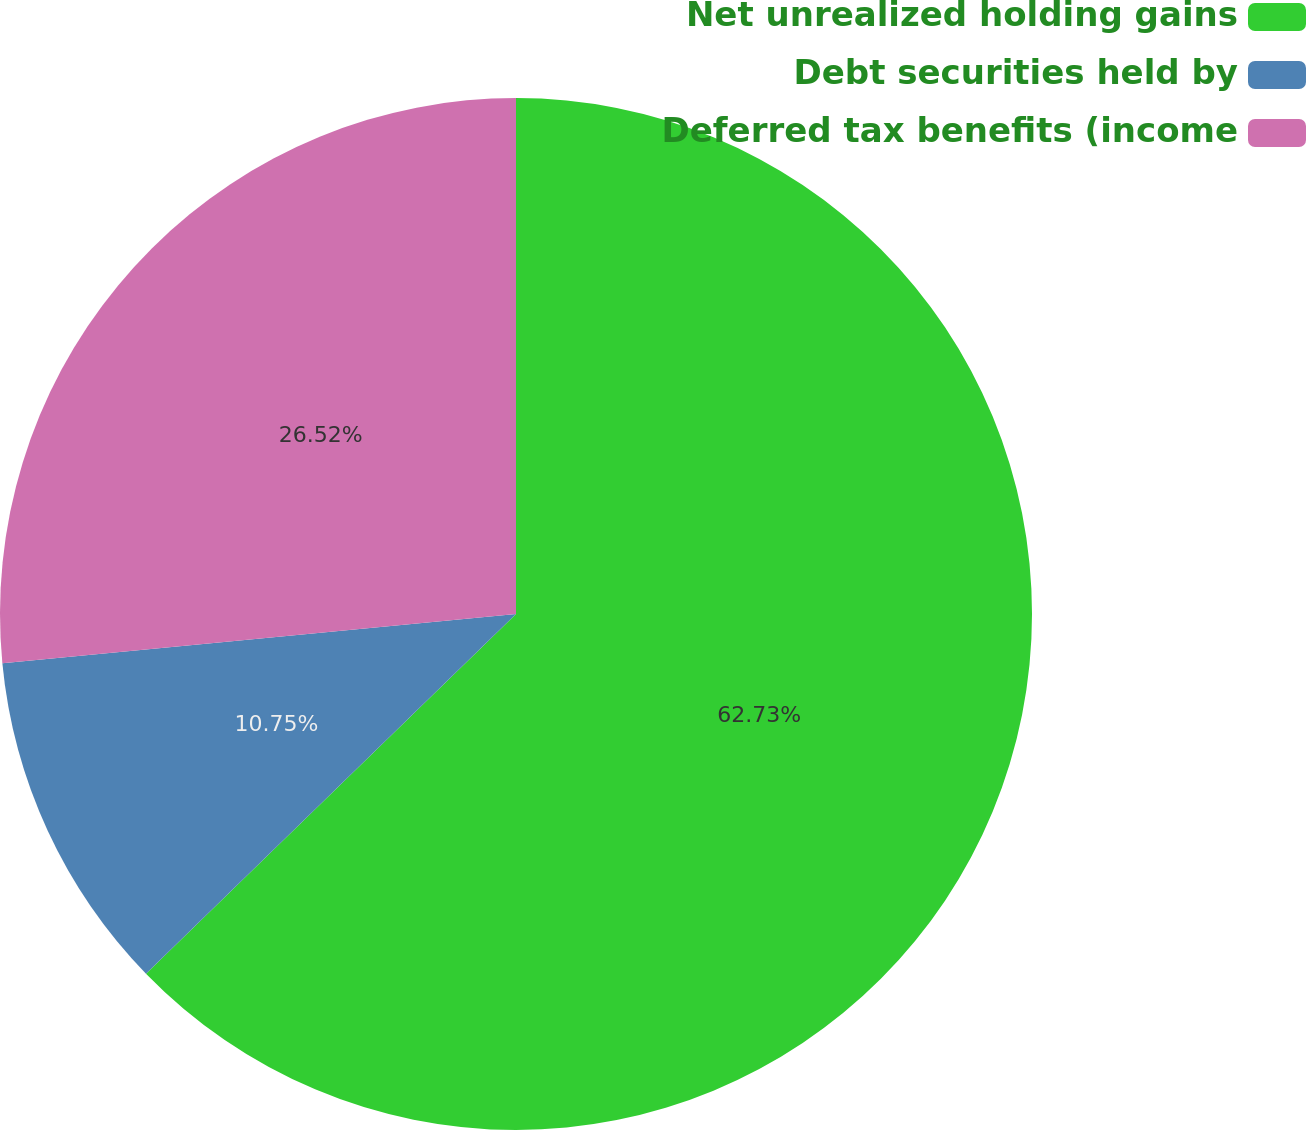Convert chart to OTSL. <chart><loc_0><loc_0><loc_500><loc_500><pie_chart><fcel>Net unrealized holding gains<fcel>Debt securities held by<fcel>Deferred tax benefits (income<nl><fcel>62.72%<fcel>10.75%<fcel>26.52%<nl></chart> 